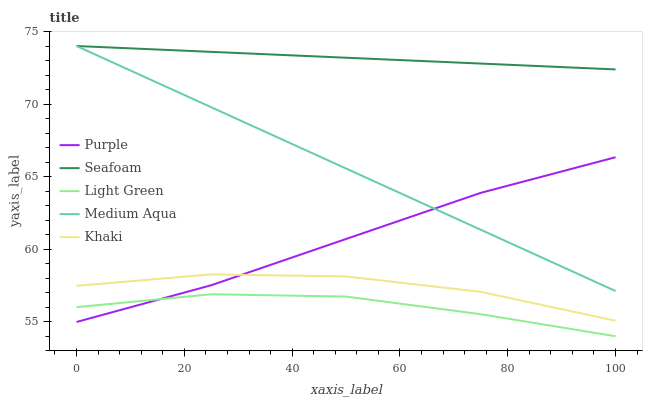Does Light Green have the minimum area under the curve?
Answer yes or no. Yes. Does Seafoam have the maximum area under the curve?
Answer yes or no. Yes. Does Khaki have the minimum area under the curve?
Answer yes or no. No. Does Khaki have the maximum area under the curve?
Answer yes or no. No. Is Seafoam the smoothest?
Answer yes or no. Yes. Is Khaki the roughest?
Answer yes or no. Yes. Is Medium Aqua the smoothest?
Answer yes or no. No. Is Medium Aqua the roughest?
Answer yes or no. No. Does Light Green have the lowest value?
Answer yes or no. Yes. Does Khaki have the lowest value?
Answer yes or no. No. Does Seafoam have the highest value?
Answer yes or no. Yes. Does Khaki have the highest value?
Answer yes or no. No. Is Light Green less than Khaki?
Answer yes or no. Yes. Is Medium Aqua greater than Light Green?
Answer yes or no. Yes. Does Light Green intersect Purple?
Answer yes or no. Yes. Is Light Green less than Purple?
Answer yes or no. No. Is Light Green greater than Purple?
Answer yes or no. No. Does Light Green intersect Khaki?
Answer yes or no. No. 